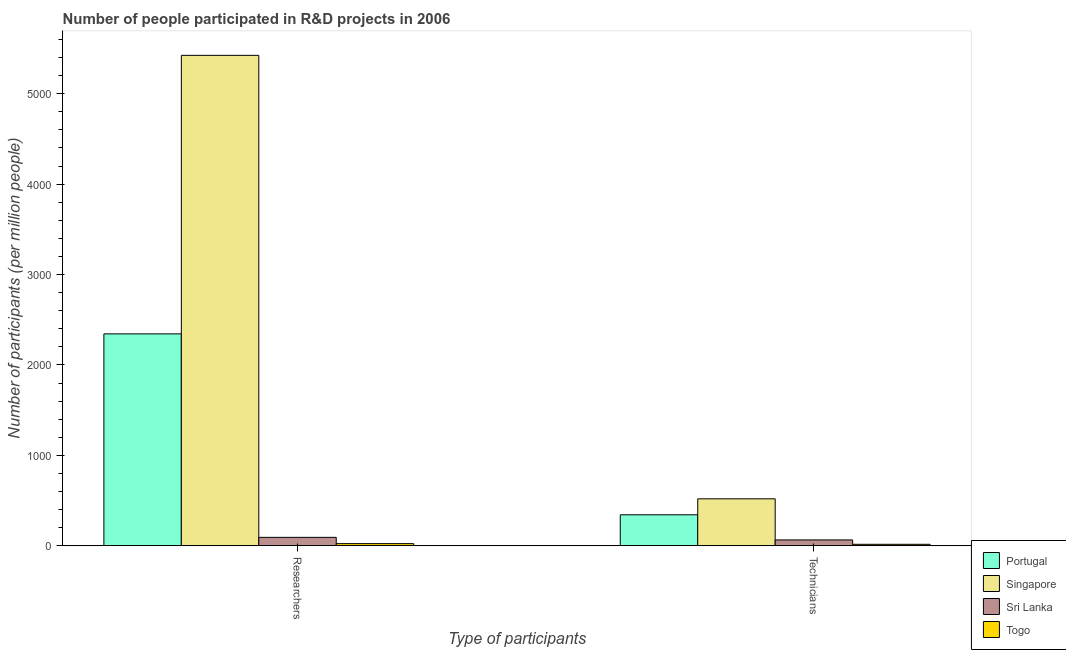How many different coloured bars are there?
Your answer should be compact. 4. Are the number of bars per tick equal to the number of legend labels?
Your answer should be very brief. Yes. Are the number of bars on each tick of the X-axis equal?
Provide a short and direct response. Yes. How many bars are there on the 1st tick from the left?
Your answer should be very brief. 4. What is the label of the 2nd group of bars from the left?
Ensure brevity in your answer.  Technicians. What is the number of researchers in Sri Lanka?
Ensure brevity in your answer.  93.18. Across all countries, what is the maximum number of technicians?
Offer a terse response. 519.4. Across all countries, what is the minimum number of researchers?
Your answer should be compact. 23.73. In which country was the number of researchers maximum?
Keep it short and to the point. Singapore. In which country was the number of technicians minimum?
Offer a terse response. Togo. What is the total number of technicians in the graph?
Your response must be concise. 943.27. What is the difference between the number of technicians in Singapore and that in Portugal?
Offer a terse response. 176.59. What is the difference between the number of researchers in Sri Lanka and the number of technicians in Singapore?
Offer a very short reply. -426.23. What is the average number of technicians per country?
Make the answer very short. 235.82. What is the difference between the number of technicians and number of researchers in Portugal?
Give a very brief answer. -2001.21. In how many countries, is the number of researchers greater than 4200 ?
Make the answer very short. 1. What is the ratio of the number of researchers in Singapore to that in Sri Lanka?
Ensure brevity in your answer.  58.22. In how many countries, is the number of technicians greater than the average number of technicians taken over all countries?
Ensure brevity in your answer.  2. What does the 3rd bar from the left in Technicians represents?
Give a very brief answer. Sri Lanka. What does the 1st bar from the right in Technicians represents?
Offer a terse response. Togo. Does the graph contain any zero values?
Give a very brief answer. No. Where does the legend appear in the graph?
Ensure brevity in your answer.  Bottom right. How are the legend labels stacked?
Your response must be concise. Vertical. What is the title of the graph?
Keep it short and to the point. Number of people participated in R&D projects in 2006. What is the label or title of the X-axis?
Your answer should be compact. Type of participants. What is the label or title of the Y-axis?
Ensure brevity in your answer.  Number of participants (per million people). What is the Number of participants (per million people) of Portugal in Researchers?
Offer a terse response. 2344.02. What is the Number of participants (per million people) in Singapore in Researchers?
Your answer should be very brief. 5424.79. What is the Number of participants (per million people) in Sri Lanka in Researchers?
Your response must be concise. 93.18. What is the Number of participants (per million people) of Togo in Researchers?
Offer a terse response. 23.73. What is the Number of participants (per million people) in Portugal in Technicians?
Offer a very short reply. 342.81. What is the Number of participants (per million people) of Singapore in Technicians?
Make the answer very short. 519.4. What is the Number of participants (per million people) of Sri Lanka in Technicians?
Ensure brevity in your answer.  64.66. What is the Number of participants (per million people) of Togo in Technicians?
Make the answer very short. 16.4. Across all Type of participants, what is the maximum Number of participants (per million people) in Portugal?
Your answer should be very brief. 2344.02. Across all Type of participants, what is the maximum Number of participants (per million people) in Singapore?
Ensure brevity in your answer.  5424.79. Across all Type of participants, what is the maximum Number of participants (per million people) in Sri Lanka?
Your answer should be very brief. 93.18. Across all Type of participants, what is the maximum Number of participants (per million people) in Togo?
Provide a short and direct response. 23.73. Across all Type of participants, what is the minimum Number of participants (per million people) in Portugal?
Ensure brevity in your answer.  342.81. Across all Type of participants, what is the minimum Number of participants (per million people) in Singapore?
Your answer should be very brief. 519.4. Across all Type of participants, what is the minimum Number of participants (per million people) in Sri Lanka?
Your response must be concise. 64.66. Across all Type of participants, what is the minimum Number of participants (per million people) in Togo?
Make the answer very short. 16.4. What is the total Number of participants (per million people) in Portugal in the graph?
Your answer should be very brief. 2686.84. What is the total Number of participants (per million people) in Singapore in the graph?
Provide a short and direct response. 5944.19. What is the total Number of participants (per million people) of Sri Lanka in the graph?
Ensure brevity in your answer.  157.84. What is the total Number of participants (per million people) in Togo in the graph?
Provide a short and direct response. 40.12. What is the difference between the Number of participants (per million people) of Portugal in Researchers and that in Technicians?
Offer a terse response. 2001.21. What is the difference between the Number of participants (per million people) of Singapore in Researchers and that in Technicians?
Ensure brevity in your answer.  4905.38. What is the difference between the Number of participants (per million people) in Sri Lanka in Researchers and that in Technicians?
Provide a succinct answer. 28.52. What is the difference between the Number of participants (per million people) in Togo in Researchers and that in Technicians?
Ensure brevity in your answer.  7.33. What is the difference between the Number of participants (per million people) of Portugal in Researchers and the Number of participants (per million people) of Singapore in Technicians?
Your response must be concise. 1824.62. What is the difference between the Number of participants (per million people) in Portugal in Researchers and the Number of participants (per million people) in Sri Lanka in Technicians?
Your answer should be very brief. 2279.37. What is the difference between the Number of participants (per million people) of Portugal in Researchers and the Number of participants (per million people) of Togo in Technicians?
Your answer should be very brief. 2327.63. What is the difference between the Number of participants (per million people) in Singapore in Researchers and the Number of participants (per million people) in Sri Lanka in Technicians?
Ensure brevity in your answer.  5360.13. What is the difference between the Number of participants (per million people) of Singapore in Researchers and the Number of participants (per million people) of Togo in Technicians?
Provide a succinct answer. 5408.39. What is the difference between the Number of participants (per million people) of Sri Lanka in Researchers and the Number of participants (per million people) of Togo in Technicians?
Your response must be concise. 76.78. What is the average Number of participants (per million people) in Portugal per Type of participants?
Make the answer very short. 1343.42. What is the average Number of participants (per million people) in Singapore per Type of participants?
Provide a short and direct response. 2972.09. What is the average Number of participants (per million people) in Sri Lanka per Type of participants?
Your answer should be very brief. 78.92. What is the average Number of participants (per million people) in Togo per Type of participants?
Ensure brevity in your answer.  20.06. What is the difference between the Number of participants (per million people) in Portugal and Number of participants (per million people) in Singapore in Researchers?
Give a very brief answer. -3080.76. What is the difference between the Number of participants (per million people) in Portugal and Number of participants (per million people) in Sri Lanka in Researchers?
Your response must be concise. 2250.85. What is the difference between the Number of participants (per million people) of Portugal and Number of participants (per million people) of Togo in Researchers?
Provide a succinct answer. 2320.3. What is the difference between the Number of participants (per million people) of Singapore and Number of participants (per million people) of Sri Lanka in Researchers?
Offer a terse response. 5331.61. What is the difference between the Number of participants (per million people) in Singapore and Number of participants (per million people) in Togo in Researchers?
Make the answer very short. 5401.06. What is the difference between the Number of participants (per million people) in Sri Lanka and Number of participants (per million people) in Togo in Researchers?
Make the answer very short. 69.45. What is the difference between the Number of participants (per million people) in Portugal and Number of participants (per million people) in Singapore in Technicians?
Make the answer very short. -176.59. What is the difference between the Number of participants (per million people) in Portugal and Number of participants (per million people) in Sri Lanka in Technicians?
Ensure brevity in your answer.  278.15. What is the difference between the Number of participants (per million people) in Portugal and Number of participants (per million people) in Togo in Technicians?
Make the answer very short. 326.41. What is the difference between the Number of participants (per million people) of Singapore and Number of participants (per million people) of Sri Lanka in Technicians?
Make the answer very short. 454.74. What is the difference between the Number of participants (per million people) in Singapore and Number of participants (per million people) in Togo in Technicians?
Provide a succinct answer. 503. What is the difference between the Number of participants (per million people) of Sri Lanka and Number of participants (per million people) of Togo in Technicians?
Provide a succinct answer. 48.26. What is the ratio of the Number of participants (per million people) in Portugal in Researchers to that in Technicians?
Your response must be concise. 6.84. What is the ratio of the Number of participants (per million people) in Singapore in Researchers to that in Technicians?
Your answer should be very brief. 10.44. What is the ratio of the Number of participants (per million people) in Sri Lanka in Researchers to that in Technicians?
Ensure brevity in your answer.  1.44. What is the ratio of the Number of participants (per million people) of Togo in Researchers to that in Technicians?
Keep it short and to the point. 1.45. What is the difference between the highest and the second highest Number of participants (per million people) in Portugal?
Provide a short and direct response. 2001.21. What is the difference between the highest and the second highest Number of participants (per million people) of Singapore?
Your answer should be compact. 4905.38. What is the difference between the highest and the second highest Number of participants (per million people) of Sri Lanka?
Your response must be concise. 28.52. What is the difference between the highest and the second highest Number of participants (per million people) of Togo?
Ensure brevity in your answer.  7.33. What is the difference between the highest and the lowest Number of participants (per million people) of Portugal?
Offer a very short reply. 2001.21. What is the difference between the highest and the lowest Number of participants (per million people) in Singapore?
Keep it short and to the point. 4905.38. What is the difference between the highest and the lowest Number of participants (per million people) in Sri Lanka?
Provide a short and direct response. 28.52. What is the difference between the highest and the lowest Number of participants (per million people) of Togo?
Provide a succinct answer. 7.33. 